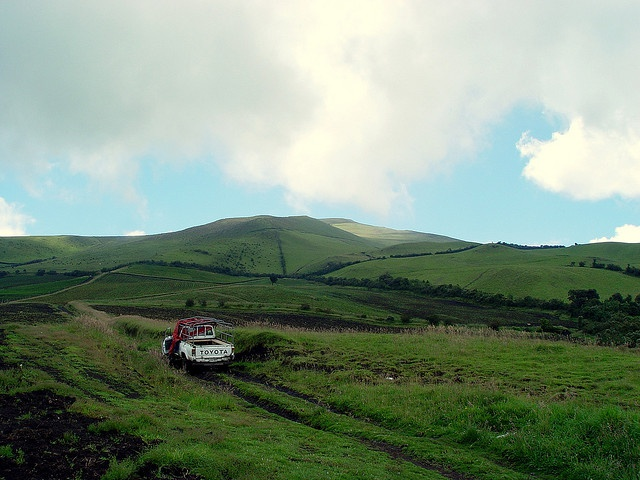Describe the objects in this image and their specific colors. I can see a truck in lightblue, black, gray, darkgray, and maroon tones in this image. 